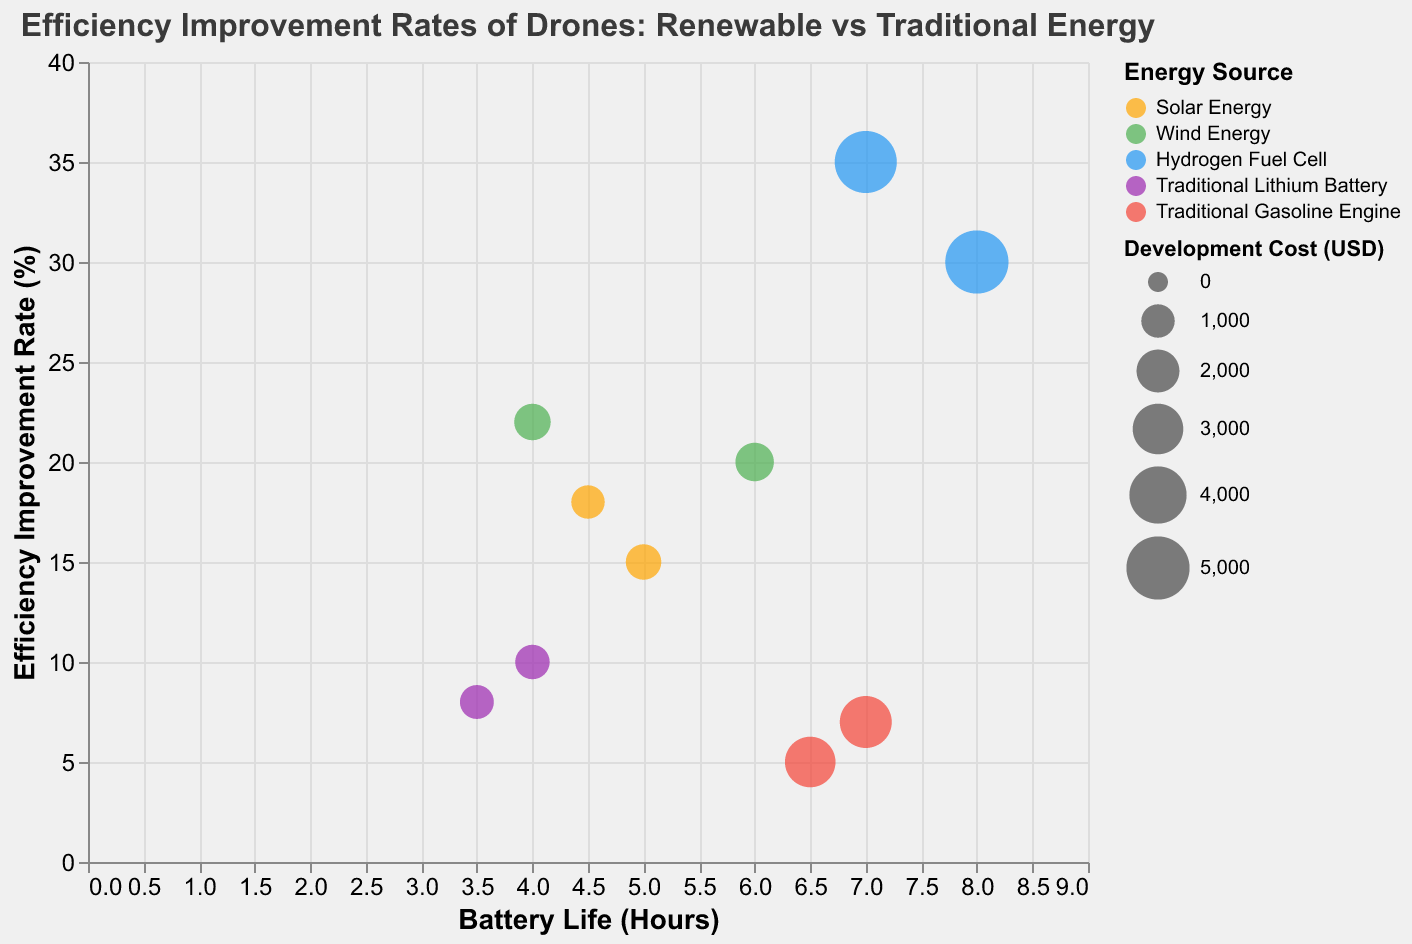How many energy sources are represented in the chart? There are five distinct colors representing each energy source.
Answer: 5 Which energy source has the highest efficiency improvement rate? The highest point on the Efficiency Improvement Rate (%) axis is associated with Hydrogen Fuel Cell.
Answer: Hydrogen Fuel Cell What is the improvement rate of the drone with the shortest battery life? The drone with the shortest battery life has 3.5 hours, and the Efficiency Improvement Rate (%) for that drone is 8%.
Answer: 8% Which drone model has the highest development cost? By looking at the size representing development cost, the largest circle in the chart corresponds to "Yuneec H520".
Answer: Yuneec H520 Compare the efficiency improvement rates of Solar Energy and Traditional Lithium Battery energy sources. Which is higher on average? Solar Energy drones have efficiency rates of 15% and 18%, averaging to (15+18)/2 = 16.5%. Traditional Lithium Battery has an average of (10+8)/2 = 9%.
Answer: Solar Energy How does battery life correlate with the efficiency improvement rate for Wind Energy drones? For Wind Energy drones, Autel Robotics Evo II has 6 hours and 20%, and Hubsan Zino has 4 hours and 22%. Longer battery life doesn't consistently correlate with higher efficiency improvement rate.
Answer: No consistent correlation Which drone model using Hydrogen Fuel Cell has a higher efficiency improvement rate? The two models using Hydrogen Fuel Cell are Yuneec H520 and Freefly Systems Alta 8. The latter has an improvement rate of 35% compared to 30% for the former.
Answer: Freefly Systems Alta 8 What is the overall trend in efficiency improvement rates across different energy sources? By observing all the data points, renewable energy sources (Solar Energy, Wind Energy, Hydrogen Fuel Cell) generally have higher efficiency improvement rates compared to traditional energy sources.
Answer: Renewable energy sources have higher rates How many drones have a battery life greater than 5 hours and what are their energy sources? Drones with battery life greater than 5 hours are Autel Robotics Evo II (Wind Energy), Yuneec H520 (Hydrogen Fuel Cell), Freefly Systems Alta 8 (Hydrogen Fuel Cell), Drone Volt Hercules 2 (Traditional Gasoline Engine), and AeroVironment Quantix (Traditional Gasoline Engine).
Answer: 5, Wind Energy, Hydrogen Fuel Cell, Traditional Gasoline Engine 